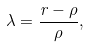Convert formula to latex. <formula><loc_0><loc_0><loc_500><loc_500>\lambda = \frac { r - \rho } { \rho } ,</formula> 